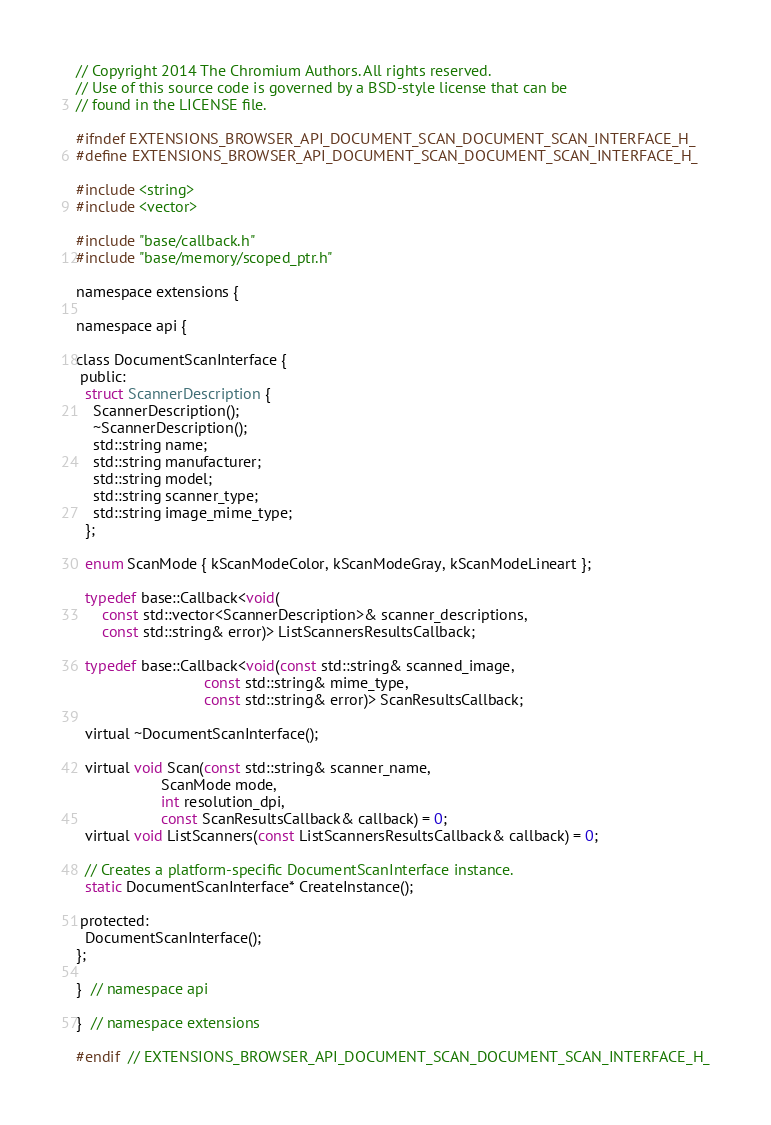<code> <loc_0><loc_0><loc_500><loc_500><_C_>// Copyright 2014 The Chromium Authors. All rights reserved.
// Use of this source code is governed by a BSD-style license that can be
// found in the LICENSE file.

#ifndef EXTENSIONS_BROWSER_API_DOCUMENT_SCAN_DOCUMENT_SCAN_INTERFACE_H_
#define EXTENSIONS_BROWSER_API_DOCUMENT_SCAN_DOCUMENT_SCAN_INTERFACE_H_

#include <string>
#include <vector>

#include "base/callback.h"
#include "base/memory/scoped_ptr.h"

namespace extensions {

namespace api {

class DocumentScanInterface {
 public:
  struct ScannerDescription {
    ScannerDescription();
    ~ScannerDescription();
    std::string name;
    std::string manufacturer;
    std::string model;
    std::string scanner_type;
    std::string image_mime_type;
  };

  enum ScanMode { kScanModeColor, kScanModeGray, kScanModeLineart };

  typedef base::Callback<void(
      const std::vector<ScannerDescription>& scanner_descriptions,
      const std::string& error)> ListScannersResultsCallback;

  typedef base::Callback<void(const std::string& scanned_image,
                              const std::string& mime_type,
                              const std::string& error)> ScanResultsCallback;

  virtual ~DocumentScanInterface();

  virtual void Scan(const std::string& scanner_name,
                    ScanMode mode,
                    int resolution_dpi,
                    const ScanResultsCallback& callback) = 0;
  virtual void ListScanners(const ListScannersResultsCallback& callback) = 0;

  // Creates a platform-specific DocumentScanInterface instance.
  static DocumentScanInterface* CreateInstance();

 protected:
  DocumentScanInterface();
};

}  // namespace api

}  // namespace extensions

#endif  // EXTENSIONS_BROWSER_API_DOCUMENT_SCAN_DOCUMENT_SCAN_INTERFACE_H_
</code> 